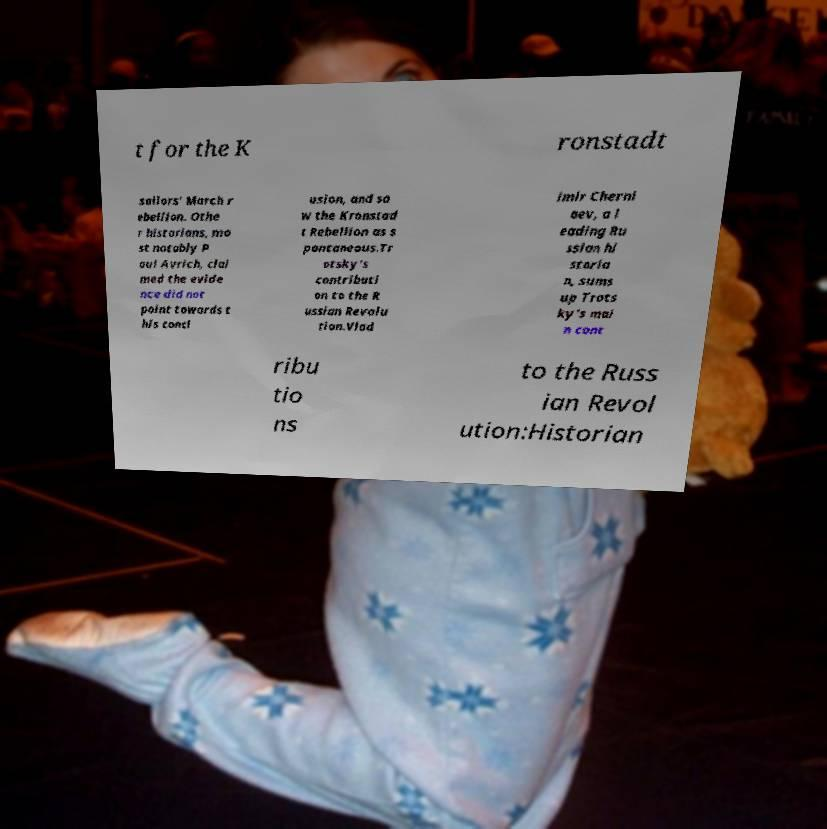I need the written content from this picture converted into text. Can you do that? t for the K ronstadt sailors' March r ebellion. Othe r historians, mo st notably P aul Avrich, clai med the evide nce did not point towards t his concl usion, and sa w the Kronstad t Rebellion as s pontaneous.Tr otsky's contributi on to the R ussian Revolu tion.Vlad imir Cherni aev, a l eading Ru ssian hi storia n, sums up Trots ky's mai n cont ribu tio ns to the Russ ian Revol ution:Historian 